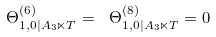<formula> <loc_0><loc_0><loc_500><loc_500>\Theta _ { 1 , 0 | A _ { 3 } \ltimes T } ^ { \left ( 6 \right ) } = \text { } \Theta _ { 1 , 0 | A _ { 3 } \ltimes T } ^ { \left ( 8 \right ) } = 0</formula> 